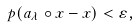<formula> <loc_0><loc_0><loc_500><loc_500>p ( a _ { \lambda } \circ x - x ) < \varepsilon ,</formula> 